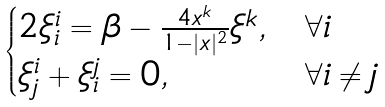<formula> <loc_0><loc_0><loc_500><loc_500>\begin{cases} 2 \xi ^ { i } _ { i } = \beta - \frac { 4 x ^ { k } } { 1 - | x | ^ { 2 } } \xi ^ { k } , & \forall i \\ \xi ^ { i } _ { j } + \xi ^ { j } _ { i } = 0 , & \forall i \not = j \end{cases}</formula> 